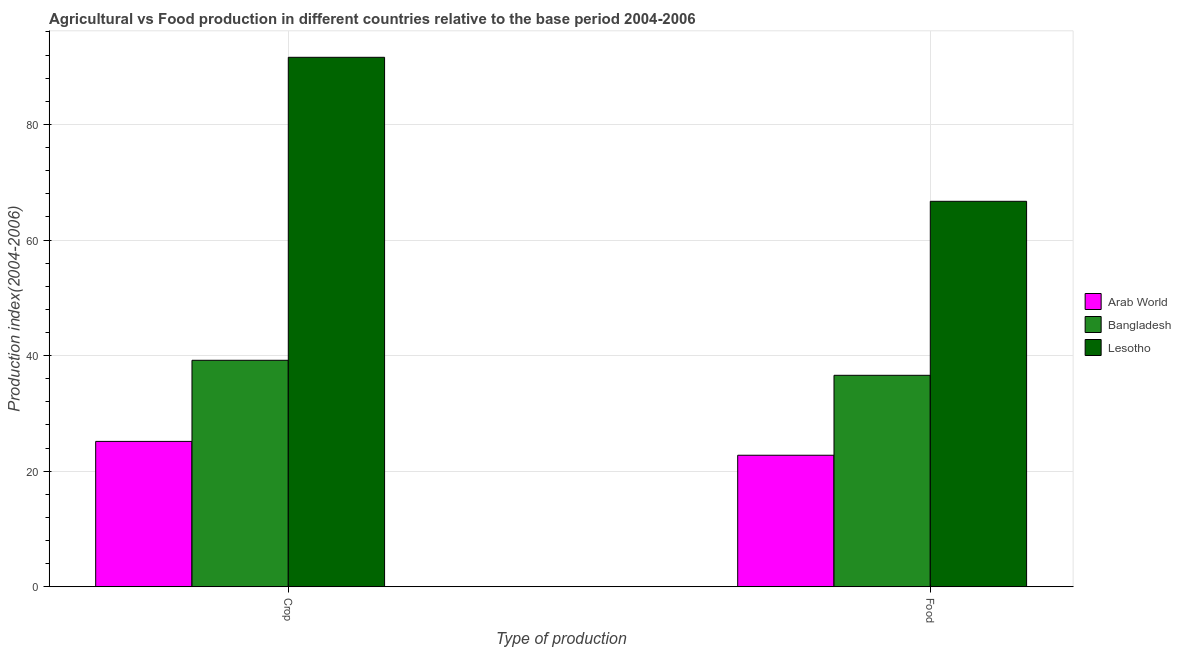How many bars are there on the 2nd tick from the left?
Provide a short and direct response. 3. What is the label of the 1st group of bars from the left?
Your answer should be very brief. Crop. What is the food production index in Lesotho?
Provide a short and direct response. 66.7. Across all countries, what is the maximum food production index?
Provide a short and direct response. 66.7. Across all countries, what is the minimum food production index?
Provide a short and direct response. 22.76. In which country was the crop production index maximum?
Make the answer very short. Lesotho. In which country was the food production index minimum?
Offer a very short reply. Arab World. What is the total crop production index in the graph?
Give a very brief answer. 155.96. What is the difference between the crop production index in Lesotho and that in Arab World?
Provide a succinct answer. 66.47. What is the difference between the food production index in Lesotho and the crop production index in Arab World?
Provide a short and direct response. 41.55. What is the average crop production index per country?
Make the answer very short. 51.99. What is the difference between the food production index and crop production index in Bangladesh?
Your answer should be very brief. -2.6. What is the ratio of the crop production index in Bangladesh to that in Lesotho?
Offer a very short reply. 0.43. Is the food production index in Arab World less than that in Bangladesh?
Your answer should be very brief. Yes. In how many countries, is the food production index greater than the average food production index taken over all countries?
Provide a short and direct response. 1. What does the 3rd bar from the left in Crop represents?
Ensure brevity in your answer.  Lesotho. What does the 1st bar from the right in Crop represents?
Provide a short and direct response. Lesotho. How many bars are there?
Your response must be concise. 6. Are the values on the major ticks of Y-axis written in scientific E-notation?
Provide a short and direct response. No. Does the graph contain any zero values?
Ensure brevity in your answer.  No. Does the graph contain grids?
Provide a short and direct response. Yes. Where does the legend appear in the graph?
Provide a succinct answer. Center right. How many legend labels are there?
Offer a very short reply. 3. How are the legend labels stacked?
Make the answer very short. Vertical. What is the title of the graph?
Make the answer very short. Agricultural vs Food production in different countries relative to the base period 2004-2006. Does "South Asia" appear as one of the legend labels in the graph?
Make the answer very short. No. What is the label or title of the X-axis?
Give a very brief answer. Type of production. What is the label or title of the Y-axis?
Offer a very short reply. Production index(2004-2006). What is the Production index(2004-2006) of Arab World in Crop?
Your answer should be very brief. 25.15. What is the Production index(2004-2006) in Bangladesh in Crop?
Provide a short and direct response. 39.19. What is the Production index(2004-2006) of Lesotho in Crop?
Ensure brevity in your answer.  91.62. What is the Production index(2004-2006) in Arab World in Food?
Offer a terse response. 22.76. What is the Production index(2004-2006) in Bangladesh in Food?
Offer a very short reply. 36.59. What is the Production index(2004-2006) in Lesotho in Food?
Your answer should be very brief. 66.7. Across all Type of production, what is the maximum Production index(2004-2006) of Arab World?
Offer a terse response. 25.15. Across all Type of production, what is the maximum Production index(2004-2006) in Bangladesh?
Provide a short and direct response. 39.19. Across all Type of production, what is the maximum Production index(2004-2006) in Lesotho?
Give a very brief answer. 91.62. Across all Type of production, what is the minimum Production index(2004-2006) in Arab World?
Your response must be concise. 22.76. Across all Type of production, what is the minimum Production index(2004-2006) of Bangladesh?
Provide a succinct answer. 36.59. Across all Type of production, what is the minimum Production index(2004-2006) in Lesotho?
Provide a succinct answer. 66.7. What is the total Production index(2004-2006) in Arab World in the graph?
Your response must be concise. 47.91. What is the total Production index(2004-2006) in Bangladesh in the graph?
Your response must be concise. 75.78. What is the total Production index(2004-2006) of Lesotho in the graph?
Keep it short and to the point. 158.32. What is the difference between the Production index(2004-2006) of Arab World in Crop and that in Food?
Your answer should be very brief. 2.4. What is the difference between the Production index(2004-2006) in Bangladesh in Crop and that in Food?
Keep it short and to the point. 2.6. What is the difference between the Production index(2004-2006) in Lesotho in Crop and that in Food?
Give a very brief answer. 24.92. What is the difference between the Production index(2004-2006) in Arab World in Crop and the Production index(2004-2006) in Bangladesh in Food?
Provide a succinct answer. -11.44. What is the difference between the Production index(2004-2006) in Arab World in Crop and the Production index(2004-2006) in Lesotho in Food?
Offer a terse response. -41.55. What is the difference between the Production index(2004-2006) of Bangladesh in Crop and the Production index(2004-2006) of Lesotho in Food?
Provide a short and direct response. -27.51. What is the average Production index(2004-2006) of Arab World per Type of production?
Your answer should be very brief. 23.96. What is the average Production index(2004-2006) in Bangladesh per Type of production?
Offer a very short reply. 37.89. What is the average Production index(2004-2006) in Lesotho per Type of production?
Offer a terse response. 79.16. What is the difference between the Production index(2004-2006) in Arab World and Production index(2004-2006) in Bangladesh in Crop?
Your answer should be compact. -14.04. What is the difference between the Production index(2004-2006) of Arab World and Production index(2004-2006) of Lesotho in Crop?
Provide a succinct answer. -66.47. What is the difference between the Production index(2004-2006) of Bangladesh and Production index(2004-2006) of Lesotho in Crop?
Keep it short and to the point. -52.43. What is the difference between the Production index(2004-2006) in Arab World and Production index(2004-2006) in Bangladesh in Food?
Give a very brief answer. -13.83. What is the difference between the Production index(2004-2006) in Arab World and Production index(2004-2006) in Lesotho in Food?
Provide a succinct answer. -43.94. What is the difference between the Production index(2004-2006) in Bangladesh and Production index(2004-2006) in Lesotho in Food?
Provide a short and direct response. -30.11. What is the ratio of the Production index(2004-2006) in Arab World in Crop to that in Food?
Offer a terse response. 1.11. What is the ratio of the Production index(2004-2006) in Bangladesh in Crop to that in Food?
Offer a terse response. 1.07. What is the ratio of the Production index(2004-2006) of Lesotho in Crop to that in Food?
Offer a very short reply. 1.37. What is the difference between the highest and the second highest Production index(2004-2006) of Arab World?
Ensure brevity in your answer.  2.4. What is the difference between the highest and the second highest Production index(2004-2006) of Lesotho?
Give a very brief answer. 24.92. What is the difference between the highest and the lowest Production index(2004-2006) in Arab World?
Offer a very short reply. 2.4. What is the difference between the highest and the lowest Production index(2004-2006) in Lesotho?
Your answer should be compact. 24.92. 